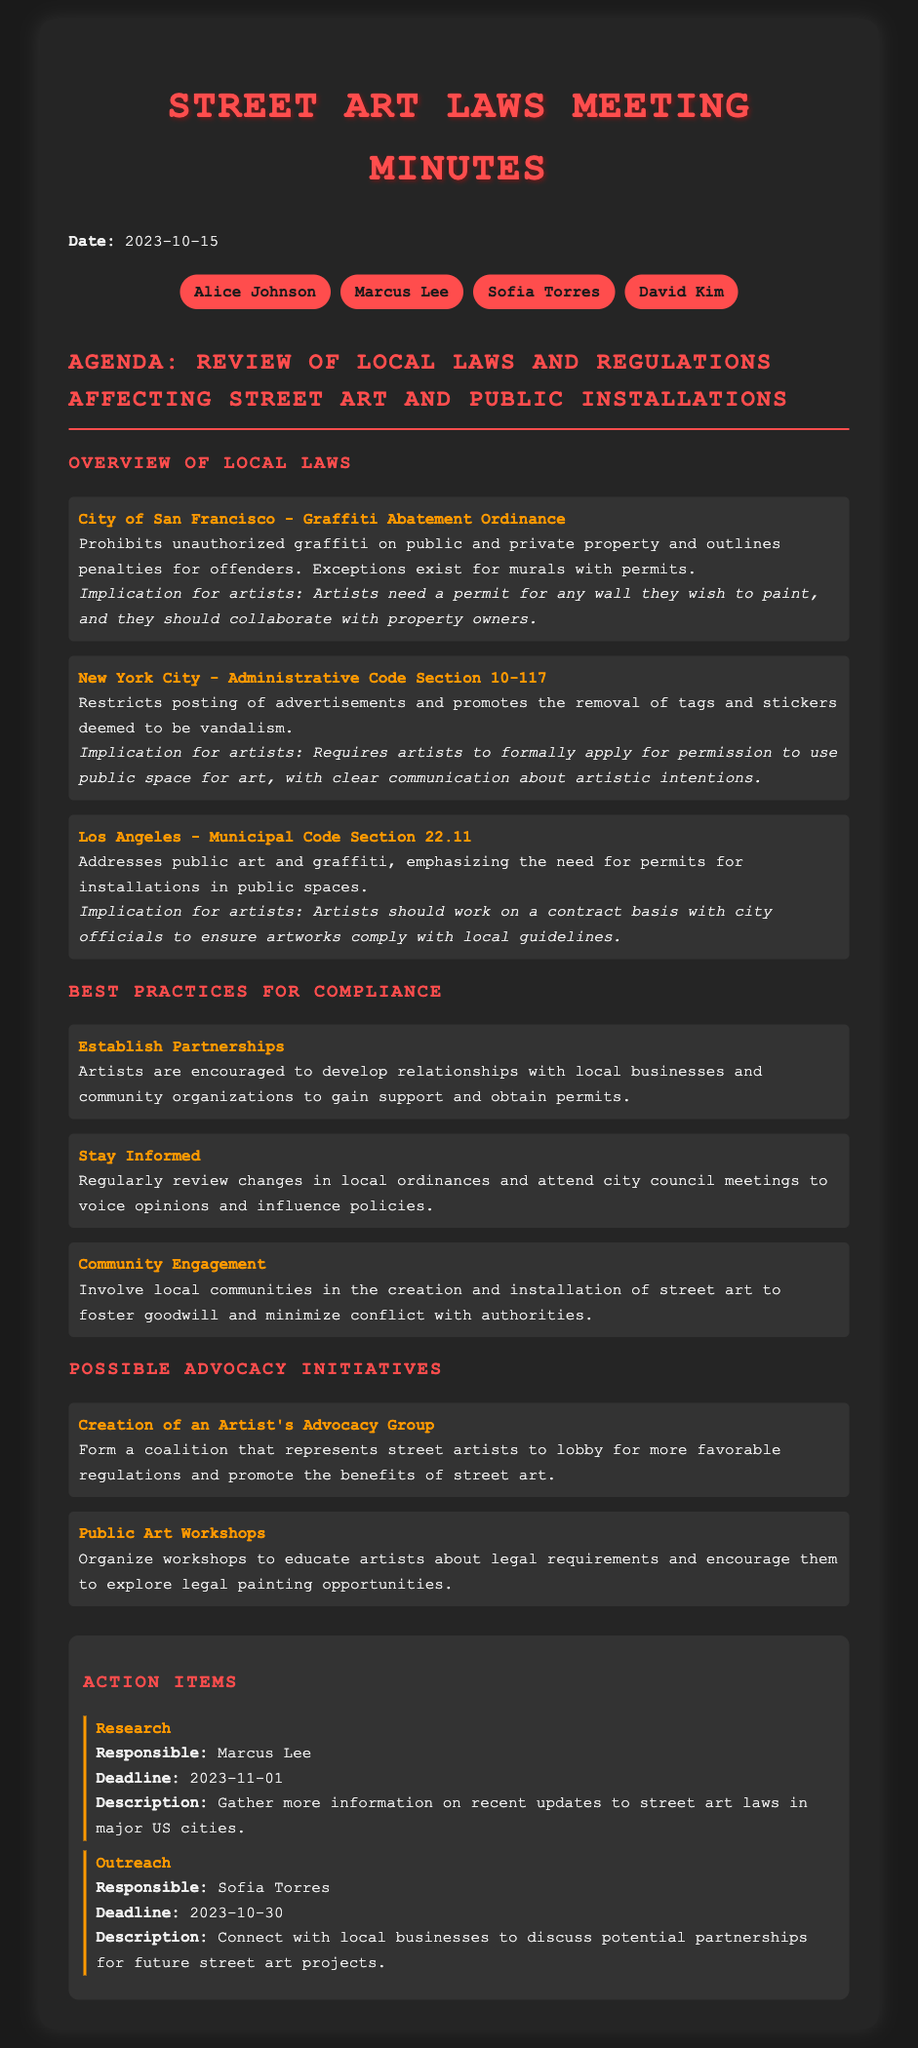What is the date of the meeting? The meeting date is clearly stated at the beginning of the document.
Answer: 2023-10-15 Who is responsible for researching updates to street art laws? The document lists action items with responsible individuals.
Answer: Marcus Lee What does the Graffiti Abatement Ordinance prohibit? The ordinance's main prohibition is detailed in the overview.
Answer: Unauthorized graffiti What is one best practice for compliance mentioned? The document lists multiple practices; one is highlighted for emphasis.
Answer: Establish Partnerships What is one possible advocacy initiative? The initiatives are listed, and one is specifically mentioned at the beginning of that section.
Answer: Creation of an Artist's Advocacy Group How many attendees were present at the meeting? The number of attendees can be counted from the attendee list.
Answer: 4 What is the deadline for Sofia Torres's outreach action? The deadline for this action is specified with dates in the action items section.
Answer: 2023-10-30 What type of laws are reviewed in this meeting? The agenda clearly states the focus of the discussion.
Answer: Local laws and regulations affecting street art 